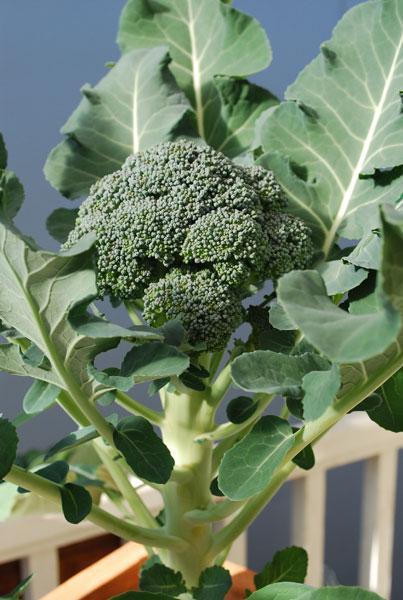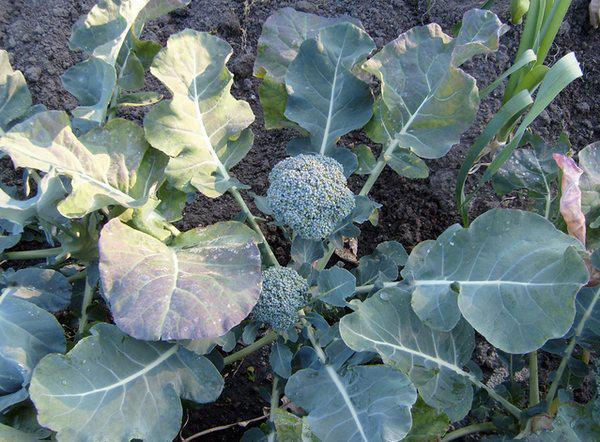The first image is the image on the left, the second image is the image on the right. For the images shown, is this caption "The left and right image contains the same number of head of broccoli." true? Answer yes or no. No. 